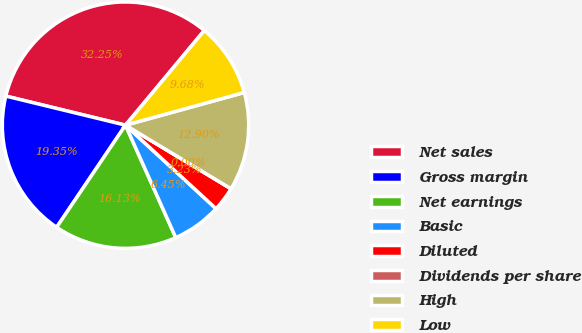<chart> <loc_0><loc_0><loc_500><loc_500><pie_chart><fcel>Net sales<fcel>Gross margin<fcel>Net earnings<fcel>Basic<fcel>Diluted<fcel>Dividends per share<fcel>High<fcel>Low<nl><fcel>32.25%<fcel>19.35%<fcel>16.13%<fcel>6.45%<fcel>3.23%<fcel>0.0%<fcel>12.9%<fcel>9.68%<nl></chart> 